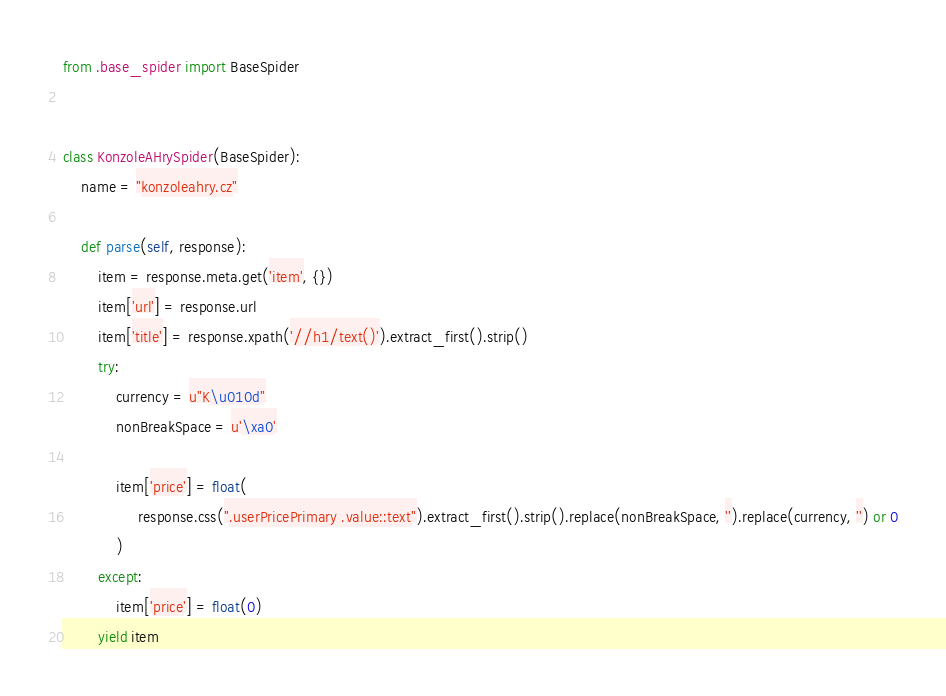<code> <loc_0><loc_0><loc_500><loc_500><_Python_>from .base_spider import BaseSpider


class KonzoleAHrySpider(BaseSpider):
    name = "konzoleahry.cz"

    def parse(self, response):
        item = response.meta.get('item', {})
        item['url'] = response.url
        item['title'] = response.xpath('//h1/text()').extract_first().strip()
        try:
            currency = u"K\u010d"
            nonBreakSpace = u'\xa0'
            
            item['price'] = float(
                 response.css(".userPricePrimary .value::text").extract_first().strip().replace(nonBreakSpace, '').replace(currency, '') or 0
            )
        except:
            item['price'] = float(0)
        yield item
</code> 